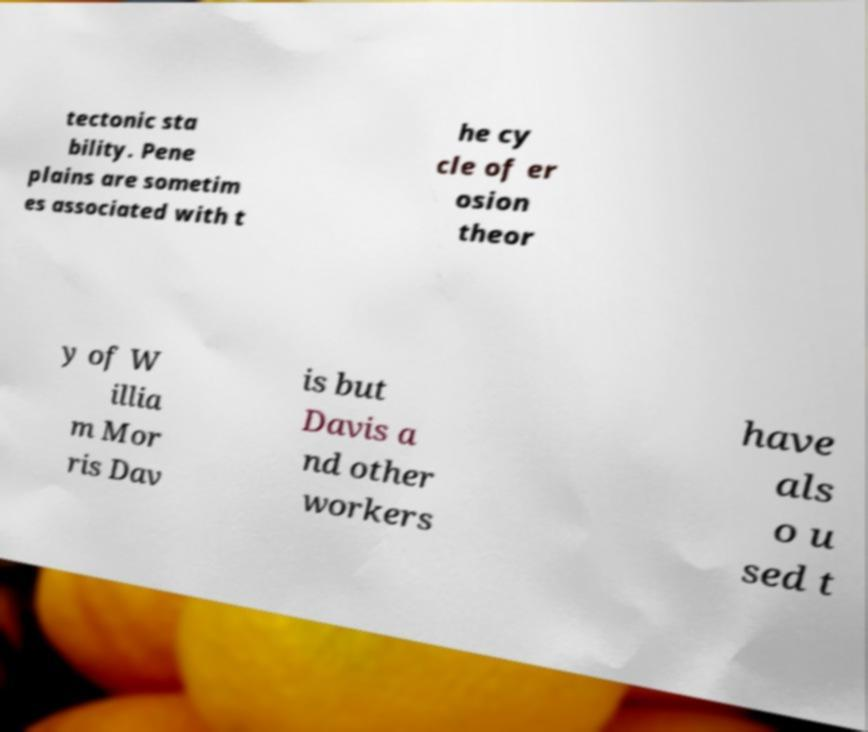For documentation purposes, I need the text within this image transcribed. Could you provide that? tectonic sta bility. Pene plains are sometim es associated with t he cy cle of er osion theor y of W illia m Mor ris Dav is but Davis a nd other workers have als o u sed t 